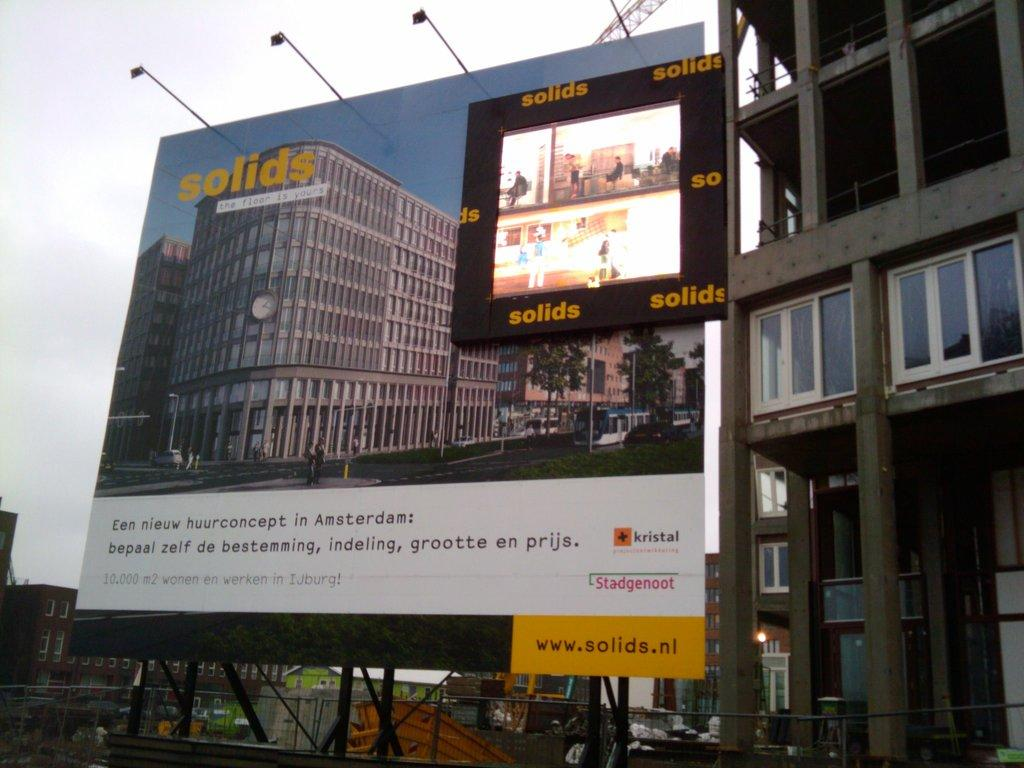<image>
Render a clear and concise summary of the photo. A large billboard sign advertising something called solids 